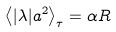<formula> <loc_0><loc_0><loc_500><loc_500>\left \langle | \lambda | a ^ { 2 } \right \rangle _ { \tau } = \alpha R</formula> 